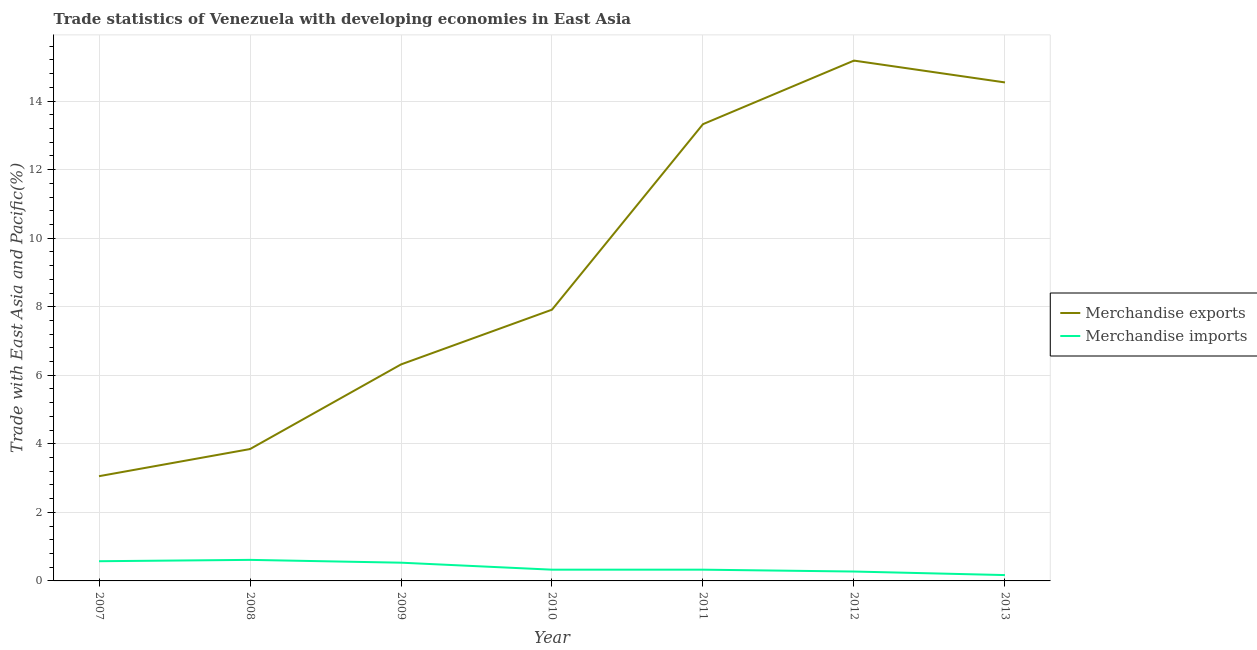How many different coloured lines are there?
Keep it short and to the point. 2. Is the number of lines equal to the number of legend labels?
Your answer should be very brief. Yes. What is the merchandise exports in 2013?
Ensure brevity in your answer.  14.54. Across all years, what is the maximum merchandise exports?
Ensure brevity in your answer.  15.18. Across all years, what is the minimum merchandise exports?
Your answer should be compact. 3.06. What is the total merchandise exports in the graph?
Your answer should be compact. 64.18. What is the difference between the merchandise imports in 2008 and that in 2012?
Make the answer very short. 0.34. What is the difference between the merchandise imports in 2012 and the merchandise exports in 2009?
Offer a very short reply. -6.04. What is the average merchandise exports per year?
Offer a very short reply. 9.17. In the year 2007, what is the difference between the merchandise exports and merchandise imports?
Make the answer very short. 2.48. In how many years, is the merchandise exports greater than 10 %?
Provide a succinct answer. 3. What is the ratio of the merchandise exports in 2008 to that in 2009?
Your answer should be compact. 0.61. What is the difference between the highest and the second highest merchandise exports?
Offer a terse response. 0.64. What is the difference between the highest and the lowest merchandise exports?
Provide a short and direct response. 12.13. In how many years, is the merchandise imports greater than the average merchandise imports taken over all years?
Give a very brief answer. 3. Does the merchandise exports monotonically increase over the years?
Provide a succinct answer. No. How many years are there in the graph?
Give a very brief answer. 7. Does the graph contain any zero values?
Your answer should be very brief. No. Where does the legend appear in the graph?
Keep it short and to the point. Center right. How many legend labels are there?
Your answer should be very brief. 2. What is the title of the graph?
Keep it short and to the point. Trade statistics of Venezuela with developing economies in East Asia. Does "Canada" appear as one of the legend labels in the graph?
Offer a terse response. No. What is the label or title of the X-axis?
Your response must be concise. Year. What is the label or title of the Y-axis?
Provide a short and direct response. Trade with East Asia and Pacific(%). What is the Trade with East Asia and Pacific(%) of Merchandise exports in 2007?
Provide a succinct answer. 3.06. What is the Trade with East Asia and Pacific(%) of Merchandise imports in 2007?
Your answer should be very brief. 0.57. What is the Trade with East Asia and Pacific(%) in Merchandise exports in 2008?
Ensure brevity in your answer.  3.85. What is the Trade with East Asia and Pacific(%) of Merchandise imports in 2008?
Your response must be concise. 0.61. What is the Trade with East Asia and Pacific(%) of Merchandise exports in 2009?
Keep it short and to the point. 6.32. What is the Trade with East Asia and Pacific(%) in Merchandise imports in 2009?
Make the answer very short. 0.53. What is the Trade with East Asia and Pacific(%) in Merchandise exports in 2010?
Your answer should be compact. 7.91. What is the Trade with East Asia and Pacific(%) in Merchandise imports in 2010?
Keep it short and to the point. 0.33. What is the Trade with East Asia and Pacific(%) in Merchandise exports in 2011?
Provide a short and direct response. 13.33. What is the Trade with East Asia and Pacific(%) in Merchandise imports in 2011?
Provide a succinct answer. 0.33. What is the Trade with East Asia and Pacific(%) of Merchandise exports in 2012?
Keep it short and to the point. 15.18. What is the Trade with East Asia and Pacific(%) in Merchandise imports in 2012?
Your answer should be compact. 0.27. What is the Trade with East Asia and Pacific(%) in Merchandise exports in 2013?
Keep it short and to the point. 14.54. What is the Trade with East Asia and Pacific(%) of Merchandise imports in 2013?
Your answer should be very brief. 0.17. Across all years, what is the maximum Trade with East Asia and Pacific(%) of Merchandise exports?
Your answer should be compact. 15.18. Across all years, what is the maximum Trade with East Asia and Pacific(%) in Merchandise imports?
Offer a very short reply. 0.61. Across all years, what is the minimum Trade with East Asia and Pacific(%) of Merchandise exports?
Offer a very short reply. 3.06. Across all years, what is the minimum Trade with East Asia and Pacific(%) of Merchandise imports?
Offer a terse response. 0.17. What is the total Trade with East Asia and Pacific(%) of Merchandise exports in the graph?
Keep it short and to the point. 64.18. What is the total Trade with East Asia and Pacific(%) of Merchandise imports in the graph?
Provide a short and direct response. 2.82. What is the difference between the Trade with East Asia and Pacific(%) in Merchandise exports in 2007 and that in 2008?
Offer a terse response. -0.79. What is the difference between the Trade with East Asia and Pacific(%) in Merchandise imports in 2007 and that in 2008?
Give a very brief answer. -0.04. What is the difference between the Trade with East Asia and Pacific(%) of Merchandise exports in 2007 and that in 2009?
Offer a very short reply. -3.26. What is the difference between the Trade with East Asia and Pacific(%) in Merchandise imports in 2007 and that in 2009?
Keep it short and to the point. 0.04. What is the difference between the Trade with East Asia and Pacific(%) of Merchandise exports in 2007 and that in 2010?
Provide a succinct answer. -4.86. What is the difference between the Trade with East Asia and Pacific(%) in Merchandise imports in 2007 and that in 2010?
Ensure brevity in your answer.  0.25. What is the difference between the Trade with East Asia and Pacific(%) of Merchandise exports in 2007 and that in 2011?
Your response must be concise. -10.27. What is the difference between the Trade with East Asia and Pacific(%) of Merchandise imports in 2007 and that in 2011?
Your response must be concise. 0.25. What is the difference between the Trade with East Asia and Pacific(%) of Merchandise exports in 2007 and that in 2012?
Make the answer very short. -12.13. What is the difference between the Trade with East Asia and Pacific(%) in Merchandise imports in 2007 and that in 2012?
Provide a succinct answer. 0.3. What is the difference between the Trade with East Asia and Pacific(%) in Merchandise exports in 2007 and that in 2013?
Offer a terse response. -11.49. What is the difference between the Trade with East Asia and Pacific(%) of Merchandise imports in 2007 and that in 2013?
Offer a terse response. 0.4. What is the difference between the Trade with East Asia and Pacific(%) in Merchandise exports in 2008 and that in 2009?
Ensure brevity in your answer.  -2.47. What is the difference between the Trade with East Asia and Pacific(%) in Merchandise imports in 2008 and that in 2009?
Provide a short and direct response. 0.08. What is the difference between the Trade with East Asia and Pacific(%) in Merchandise exports in 2008 and that in 2010?
Give a very brief answer. -4.07. What is the difference between the Trade with East Asia and Pacific(%) in Merchandise imports in 2008 and that in 2010?
Offer a very short reply. 0.29. What is the difference between the Trade with East Asia and Pacific(%) of Merchandise exports in 2008 and that in 2011?
Offer a very short reply. -9.48. What is the difference between the Trade with East Asia and Pacific(%) of Merchandise imports in 2008 and that in 2011?
Your response must be concise. 0.29. What is the difference between the Trade with East Asia and Pacific(%) of Merchandise exports in 2008 and that in 2012?
Offer a terse response. -11.33. What is the difference between the Trade with East Asia and Pacific(%) of Merchandise imports in 2008 and that in 2012?
Ensure brevity in your answer.  0.34. What is the difference between the Trade with East Asia and Pacific(%) of Merchandise exports in 2008 and that in 2013?
Keep it short and to the point. -10.7. What is the difference between the Trade with East Asia and Pacific(%) in Merchandise imports in 2008 and that in 2013?
Your answer should be very brief. 0.44. What is the difference between the Trade with East Asia and Pacific(%) of Merchandise exports in 2009 and that in 2010?
Give a very brief answer. -1.6. What is the difference between the Trade with East Asia and Pacific(%) in Merchandise imports in 2009 and that in 2010?
Make the answer very short. 0.2. What is the difference between the Trade with East Asia and Pacific(%) in Merchandise exports in 2009 and that in 2011?
Keep it short and to the point. -7.01. What is the difference between the Trade with East Asia and Pacific(%) in Merchandise imports in 2009 and that in 2011?
Offer a very short reply. 0.2. What is the difference between the Trade with East Asia and Pacific(%) of Merchandise exports in 2009 and that in 2012?
Offer a terse response. -8.86. What is the difference between the Trade with East Asia and Pacific(%) of Merchandise imports in 2009 and that in 2012?
Give a very brief answer. 0.26. What is the difference between the Trade with East Asia and Pacific(%) of Merchandise exports in 2009 and that in 2013?
Offer a terse response. -8.23. What is the difference between the Trade with East Asia and Pacific(%) of Merchandise imports in 2009 and that in 2013?
Offer a very short reply. 0.36. What is the difference between the Trade with East Asia and Pacific(%) of Merchandise exports in 2010 and that in 2011?
Keep it short and to the point. -5.41. What is the difference between the Trade with East Asia and Pacific(%) of Merchandise exports in 2010 and that in 2012?
Offer a terse response. -7.27. What is the difference between the Trade with East Asia and Pacific(%) in Merchandise imports in 2010 and that in 2012?
Your answer should be very brief. 0.05. What is the difference between the Trade with East Asia and Pacific(%) in Merchandise exports in 2010 and that in 2013?
Provide a short and direct response. -6.63. What is the difference between the Trade with East Asia and Pacific(%) in Merchandise imports in 2010 and that in 2013?
Offer a terse response. 0.16. What is the difference between the Trade with East Asia and Pacific(%) of Merchandise exports in 2011 and that in 2012?
Provide a short and direct response. -1.85. What is the difference between the Trade with East Asia and Pacific(%) in Merchandise imports in 2011 and that in 2012?
Keep it short and to the point. 0.05. What is the difference between the Trade with East Asia and Pacific(%) in Merchandise exports in 2011 and that in 2013?
Give a very brief answer. -1.22. What is the difference between the Trade with East Asia and Pacific(%) in Merchandise imports in 2011 and that in 2013?
Your response must be concise. 0.16. What is the difference between the Trade with East Asia and Pacific(%) in Merchandise exports in 2012 and that in 2013?
Ensure brevity in your answer.  0.64. What is the difference between the Trade with East Asia and Pacific(%) in Merchandise imports in 2012 and that in 2013?
Offer a terse response. 0.1. What is the difference between the Trade with East Asia and Pacific(%) of Merchandise exports in 2007 and the Trade with East Asia and Pacific(%) of Merchandise imports in 2008?
Make the answer very short. 2.44. What is the difference between the Trade with East Asia and Pacific(%) of Merchandise exports in 2007 and the Trade with East Asia and Pacific(%) of Merchandise imports in 2009?
Your response must be concise. 2.52. What is the difference between the Trade with East Asia and Pacific(%) of Merchandise exports in 2007 and the Trade with East Asia and Pacific(%) of Merchandise imports in 2010?
Offer a terse response. 2.73. What is the difference between the Trade with East Asia and Pacific(%) in Merchandise exports in 2007 and the Trade with East Asia and Pacific(%) in Merchandise imports in 2011?
Keep it short and to the point. 2.73. What is the difference between the Trade with East Asia and Pacific(%) in Merchandise exports in 2007 and the Trade with East Asia and Pacific(%) in Merchandise imports in 2012?
Your answer should be very brief. 2.78. What is the difference between the Trade with East Asia and Pacific(%) in Merchandise exports in 2007 and the Trade with East Asia and Pacific(%) in Merchandise imports in 2013?
Your answer should be compact. 2.89. What is the difference between the Trade with East Asia and Pacific(%) of Merchandise exports in 2008 and the Trade with East Asia and Pacific(%) of Merchandise imports in 2009?
Ensure brevity in your answer.  3.31. What is the difference between the Trade with East Asia and Pacific(%) in Merchandise exports in 2008 and the Trade with East Asia and Pacific(%) in Merchandise imports in 2010?
Ensure brevity in your answer.  3.52. What is the difference between the Trade with East Asia and Pacific(%) in Merchandise exports in 2008 and the Trade with East Asia and Pacific(%) in Merchandise imports in 2011?
Your response must be concise. 3.52. What is the difference between the Trade with East Asia and Pacific(%) of Merchandise exports in 2008 and the Trade with East Asia and Pacific(%) of Merchandise imports in 2012?
Provide a succinct answer. 3.57. What is the difference between the Trade with East Asia and Pacific(%) of Merchandise exports in 2008 and the Trade with East Asia and Pacific(%) of Merchandise imports in 2013?
Give a very brief answer. 3.68. What is the difference between the Trade with East Asia and Pacific(%) of Merchandise exports in 2009 and the Trade with East Asia and Pacific(%) of Merchandise imports in 2010?
Your response must be concise. 5.99. What is the difference between the Trade with East Asia and Pacific(%) of Merchandise exports in 2009 and the Trade with East Asia and Pacific(%) of Merchandise imports in 2011?
Provide a succinct answer. 5.99. What is the difference between the Trade with East Asia and Pacific(%) of Merchandise exports in 2009 and the Trade with East Asia and Pacific(%) of Merchandise imports in 2012?
Your answer should be compact. 6.04. What is the difference between the Trade with East Asia and Pacific(%) of Merchandise exports in 2009 and the Trade with East Asia and Pacific(%) of Merchandise imports in 2013?
Provide a succinct answer. 6.15. What is the difference between the Trade with East Asia and Pacific(%) of Merchandise exports in 2010 and the Trade with East Asia and Pacific(%) of Merchandise imports in 2011?
Give a very brief answer. 7.59. What is the difference between the Trade with East Asia and Pacific(%) in Merchandise exports in 2010 and the Trade with East Asia and Pacific(%) in Merchandise imports in 2012?
Provide a short and direct response. 7.64. What is the difference between the Trade with East Asia and Pacific(%) of Merchandise exports in 2010 and the Trade with East Asia and Pacific(%) of Merchandise imports in 2013?
Give a very brief answer. 7.74. What is the difference between the Trade with East Asia and Pacific(%) in Merchandise exports in 2011 and the Trade with East Asia and Pacific(%) in Merchandise imports in 2012?
Offer a terse response. 13.05. What is the difference between the Trade with East Asia and Pacific(%) of Merchandise exports in 2011 and the Trade with East Asia and Pacific(%) of Merchandise imports in 2013?
Your answer should be compact. 13.16. What is the difference between the Trade with East Asia and Pacific(%) in Merchandise exports in 2012 and the Trade with East Asia and Pacific(%) in Merchandise imports in 2013?
Offer a terse response. 15.01. What is the average Trade with East Asia and Pacific(%) in Merchandise exports per year?
Ensure brevity in your answer.  9.17. What is the average Trade with East Asia and Pacific(%) in Merchandise imports per year?
Offer a terse response. 0.4. In the year 2007, what is the difference between the Trade with East Asia and Pacific(%) of Merchandise exports and Trade with East Asia and Pacific(%) of Merchandise imports?
Make the answer very short. 2.48. In the year 2008, what is the difference between the Trade with East Asia and Pacific(%) of Merchandise exports and Trade with East Asia and Pacific(%) of Merchandise imports?
Offer a very short reply. 3.23. In the year 2009, what is the difference between the Trade with East Asia and Pacific(%) in Merchandise exports and Trade with East Asia and Pacific(%) in Merchandise imports?
Keep it short and to the point. 5.78. In the year 2010, what is the difference between the Trade with East Asia and Pacific(%) of Merchandise exports and Trade with East Asia and Pacific(%) of Merchandise imports?
Make the answer very short. 7.59. In the year 2011, what is the difference between the Trade with East Asia and Pacific(%) of Merchandise exports and Trade with East Asia and Pacific(%) of Merchandise imports?
Your answer should be compact. 13. In the year 2012, what is the difference between the Trade with East Asia and Pacific(%) of Merchandise exports and Trade with East Asia and Pacific(%) of Merchandise imports?
Your response must be concise. 14.91. In the year 2013, what is the difference between the Trade with East Asia and Pacific(%) in Merchandise exports and Trade with East Asia and Pacific(%) in Merchandise imports?
Ensure brevity in your answer.  14.37. What is the ratio of the Trade with East Asia and Pacific(%) in Merchandise exports in 2007 to that in 2008?
Keep it short and to the point. 0.79. What is the ratio of the Trade with East Asia and Pacific(%) of Merchandise imports in 2007 to that in 2008?
Offer a terse response. 0.94. What is the ratio of the Trade with East Asia and Pacific(%) in Merchandise exports in 2007 to that in 2009?
Offer a very short reply. 0.48. What is the ratio of the Trade with East Asia and Pacific(%) in Merchandise imports in 2007 to that in 2009?
Make the answer very short. 1.08. What is the ratio of the Trade with East Asia and Pacific(%) of Merchandise exports in 2007 to that in 2010?
Your answer should be very brief. 0.39. What is the ratio of the Trade with East Asia and Pacific(%) in Merchandise imports in 2007 to that in 2010?
Your answer should be compact. 1.75. What is the ratio of the Trade with East Asia and Pacific(%) of Merchandise exports in 2007 to that in 2011?
Keep it short and to the point. 0.23. What is the ratio of the Trade with East Asia and Pacific(%) in Merchandise imports in 2007 to that in 2011?
Offer a terse response. 1.75. What is the ratio of the Trade with East Asia and Pacific(%) in Merchandise exports in 2007 to that in 2012?
Ensure brevity in your answer.  0.2. What is the ratio of the Trade with East Asia and Pacific(%) of Merchandise imports in 2007 to that in 2012?
Give a very brief answer. 2.1. What is the ratio of the Trade with East Asia and Pacific(%) of Merchandise exports in 2007 to that in 2013?
Make the answer very short. 0.21. What is the ratio of the Trade with East Asia and Pacific(%) in Merchandise imports in 2007 to that in 2013?
Give a very brief answer. 3.38. What is the ratio of the Trade with East Asia and Pacific(%) in Merchandise exports in 2008 to that in 2009?
Your answer should be very brief. 0.61. What is the ratio of the Trade with East Asia and Pacific(%) of Merchandise imports in 2008 to that in 2009?
Make the answer very short. 1.15. What is the ratio of the Trade with East Asia and Pacific(%) of Merchandise exports in 2008 to that in 2010?
Ensure brevity in your answer.  0.49. What is the ratio of the Trade with East Asia and Pacific(%) of Merchandise imports in 2008 to that in 2010?
Your response must be concise. 1.87. What is the ratio of the Trade with East Asia and Pacific(%) of Merchandise exports in 2008 to that in 2011?
Offer a terse response. 0.29. What is the ratio of the Trade with East Asia and Pacific(%) in Merchandise imports in 2008 to that in 2011?
Offer a very short reply. 1.87. What is the ratio of the Trade with East Asia and Pacific(%) in Merchandise exports in 2008 to that in 2012?
Provide a short and direct response. 0.25. What is the ratio of the Trade with East Asia and Pacific(%) in Merchandise imports in 2008 to that in 2012?
Offer a very short reply. 2.24. What is the ratio of the Trade with East Asia and Pacific(%) in Merchandise exports in 2008 to that in 2013?
Offer a very short reply. 0.26. What is the ratio of the Trade with East Asia and Pacific(%) in Merchandise imports in 2008 to that in 2013?
Make the answer very short. 3.61. What is the ratio of the Trade with East Asia and Pacific(%) in Merchandise exports in 2009 to that in 2010?
Your answer should be compact. 0.8. What is the ratio of the Trade with East Asia and Pacific(%) in Merchandise imports in 2009 to that in 2010?
Provide a short and direct response. 1.62. What is the ratio of the Trade with East Asia and Pacific(%) of Merchandise exports in 2009 to that in 2011?
Offer a very short reply. 0.47. What is the ratio of the Trade with East Asia and Pacific(%) of Merchandise imports in 2009 to that in 2011?
Your answer should be very brief. 1.62. What is the ratio of the Trade with East Asia and Pacific(%) of Merchandise exports in 2009 to that in 2012?
Your response must be concise. 0.42. What is the ratio of the Trade with East Asia and Pacific(%) of Merchandise imports in 2009 to that in 2012?
Keep it short and to the point. 1.94. What is the ratio of the Trade with East Asia and Pacific(%) in Merchandise exports in 2009 to that in 2013?
Your response must be concise. 0.43. What is the ratio of the Trade with East Asia and Pacific(%) in Merchandise imports in 2009 to that in 2013?
Your answer should be compact. 3.13. What is the ratio of the Trade with East Asia and Pacific(%) of Merchandise exports in 2010 to that in 2011?
Your answer should be very brief. 0.59. What is the ratio of the Trade with East Asia and Pacific(%) of Merchandise imports in 2010 to that in 2011?
Offer a terse response. 1. What is the ratio of the Trade with East Asia and Pacific(%) in Merchandise exports in 2010 to that in 2012?
Offer a very short reply. 0.52. What is the ratio of the Trade with East Asia and Pacific(%) in Merchandise imports in 2010 to that in 2012?
Provide a succinct answer. 1.2. What is the ratio of the Trade with East Asia and Pacific(%) of Merchandise exports in 2010 to that in 2013?
Ensure brevity in your answer.  0.54. What is the ratio of the Trade with East Asia and Pacific(%) of Merchandise imports in 2010 to that in 2013?
Keep it short and to the point. 1.93. What is the ratio of the Trade with East Asia and Pacific(%) of Merchandise exports in 2011 to that in 2012?
Offer a very short reply. 0.88. What is the ratio of the Trade with East Asia and Pacific(%) in Merchandise imports in 2011 to that in 2012?
Offer a very short reply. 1.2. What is the ratio of the Trade with East Asia and Pacific(%) in Merchandise exports in 2011 to that in 2013?
Offer a very short reply. 0.92. What is the ratio of the Trade with East Asia and Pacific(%) of Merchandise imports in 2011 to that in 2013?
Offer a terse response. 1.93. What is the ratio of the Trade with East Asia and Pacific(%) in Merchandise exports in 2012 to that in 2013?
Ensure brevity in your answer.  1.04. What is the ratio of the Trade with East Asia and Pacific(%) in Merchandise imports in 2012 to that in 2013?
Provide a short and direct response. 1.61. What is the difference between the highest and the second highest Trade with East Asia and Pacific(%) of Merchandise exports?
Give a very brief answer. 0.64. What is the difference between the highest and the second highest Trade with East Asia and Pacific(%) of Merchandise imports?
Give a very brief answer. 0.04. What is the difference between the highest and the lowest Trade with East Asia and Pacific(%) of Merchandise exports?
Offer a very short reply. 12.13. What is the difference between the highest and the lowest Trade with East Asia and Pacific(%) of Merchandise imports?
Your answer should be very brief. 0.44. 